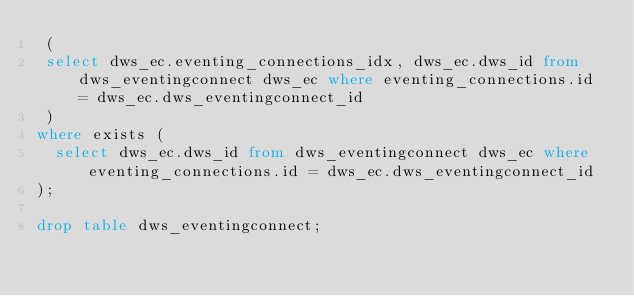Convert code to text. <code><loc_0><loc_0><loc_500><loc_500><_SQL_> (
 select dws_ec.eventing_connections_idx, dws_ec.dws_id from dws_eventingconnect dws_ec where eventing_connections.id = dws_ec.dws_eventingconnect_id
 )
where exists (
  select dws_ec.dws_id from dws_eventingconnect dws_ec where eventing_connections.id = dws_ec.dws_eventingconnect_id
);

drop table dws_eventingconnect;


</code> 